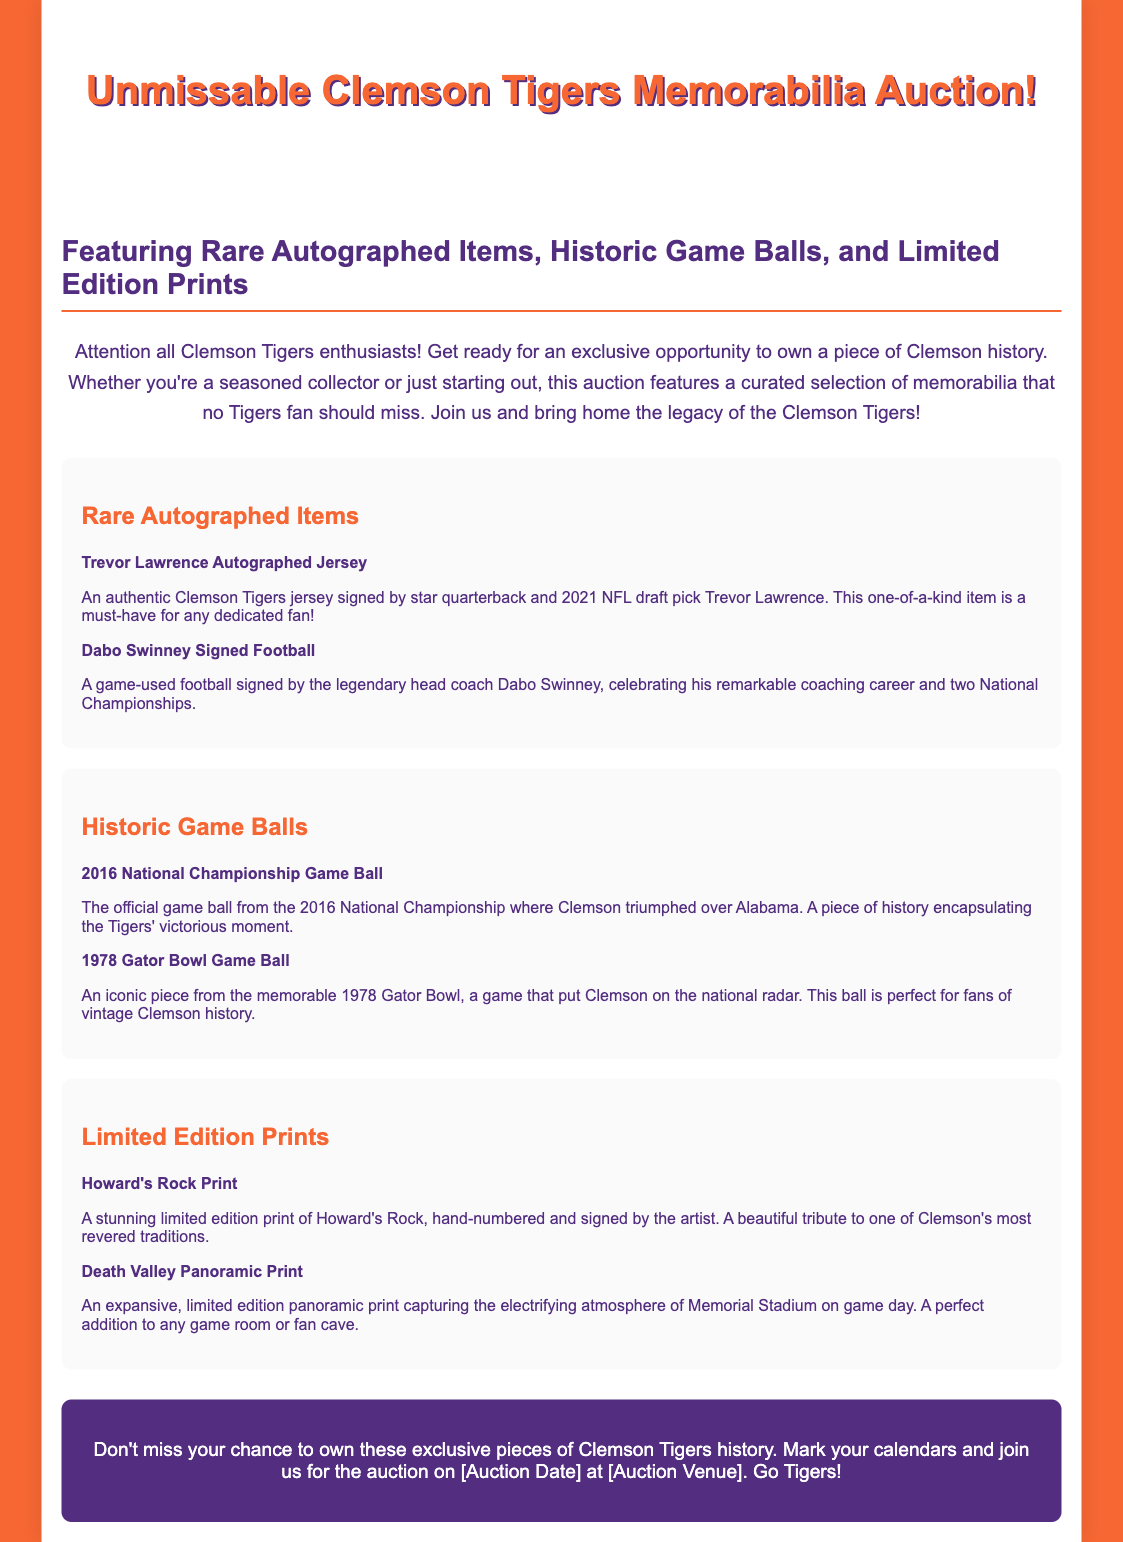What is the title of the auction? The title of the auction is mentioned prominently at the top of the document.
Answer: Unmissable Clemson Tigers Memorabilia Auction! What type of items are featured in the auction? The document specifies the types of items available in the auction right after the title.
Answer: Rare Autographed Items, Historic Game Balls, and Limited Edition Prints Who signed the jersey mentioned in the auction? The document lists specific items and their descriptions, including the jersey's signer.
Answer: Trevor Lawrence What is the year of the National Championship game ball? The document provides information about significant items, including the game ball's historical context.
Answer: 2016 What is the name of one historic game mentioned in the auction? The document highlights specific historic game balls and provides their names.
Answer: 1978 Gator Bowl Game Ball What is hand-numbered and signed by the artist? The document describes a specific item related to Clemson's traditions.
Answer: Howard's Rock Print Which item captures the atmosphere of Memorial Stadium? The document mentions specific items that represent Clemson's game environment.
Answer: Death Valley Panoramic Print What should you mark on your calendar for the auction? The document encourages readers to prepare for the auction by mentioning a specific action.
Answer: Auction Date 